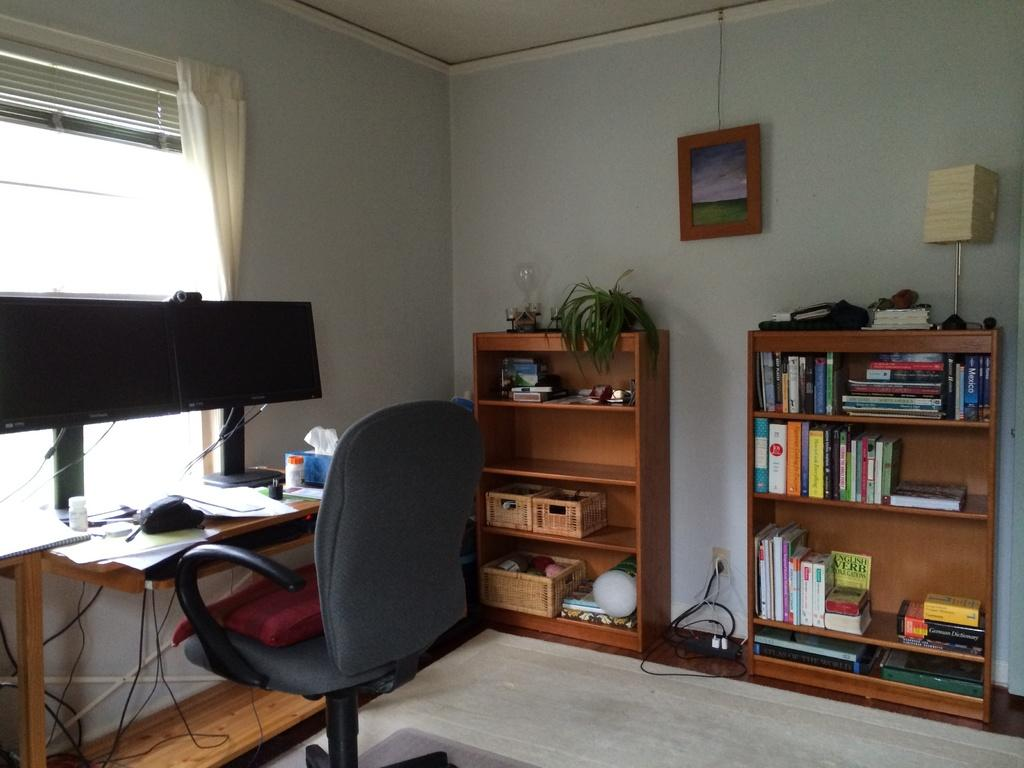What piece of furniture is in the image? There is a chair in the image. Where is the chair located in relation to the table? The chair is in front of a table. How many desktops are on the table? The table has two desktops. What can be seen on the table? There are papers on the table. What is located in the right corner of the image? There is a bookshelf in the right corner of the image. What type of dress is hanging on the chair in the image? There is no dress present in the image; only a chair, table, papers, and a bookshelf are visible. 